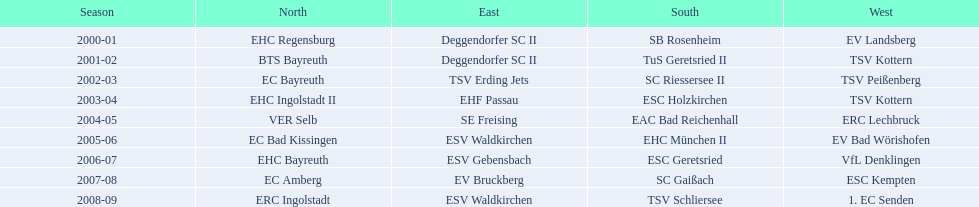Who won the south after esc geretsried did during the 2006-07 season? SC Gaißach. 